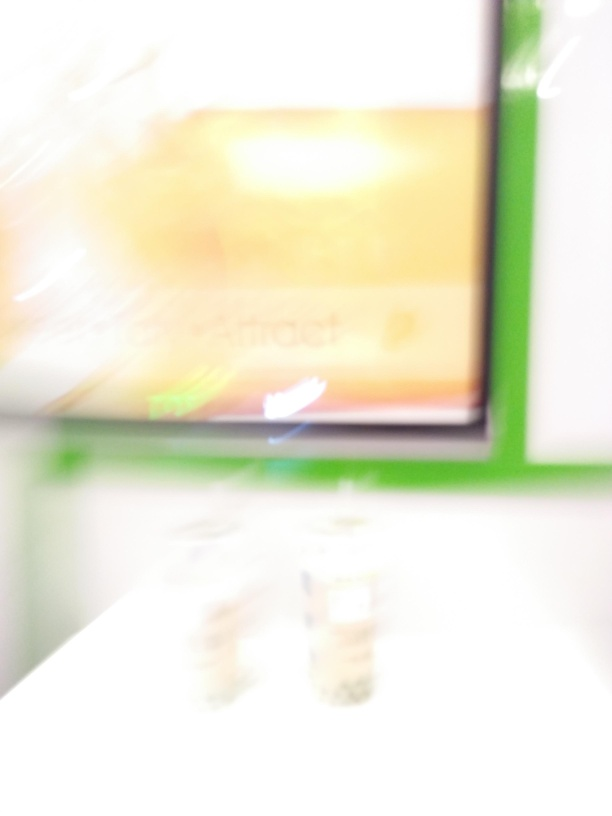What are the main subjects in this image? It's challenging to ascertain the specifics within this image due to the significant blur, but it appears that we're looking at an interior space with some form of lighting and possibly printed or digital displays. A sharper image would be necessary to provide a detailed description of the subjects present. 